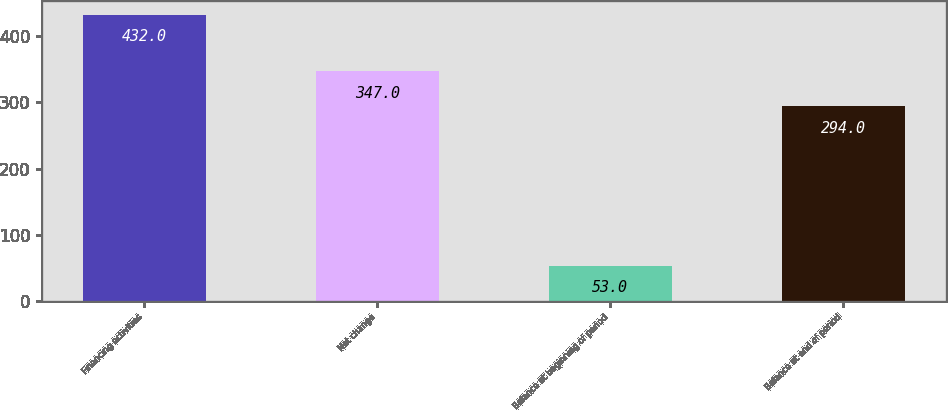Convert chart. <chart><loc_0><loc_0><loc_500><loc_500><bar_chart><fcel>Financing activities<fcel>Net change<fcel>Balance at beginning of period<fcel>Balance at end of period<nl><fcel>432<fcel>347<fcel>53<fcel>294<nl></chart> 